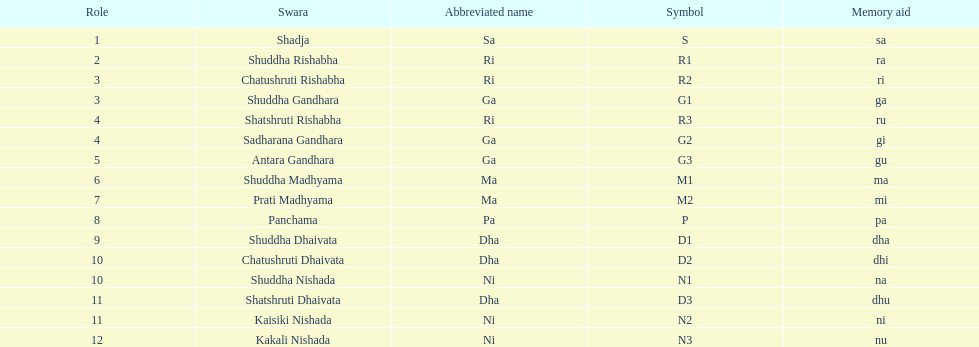What is the name of the swara that holds the first position? Shadja. 